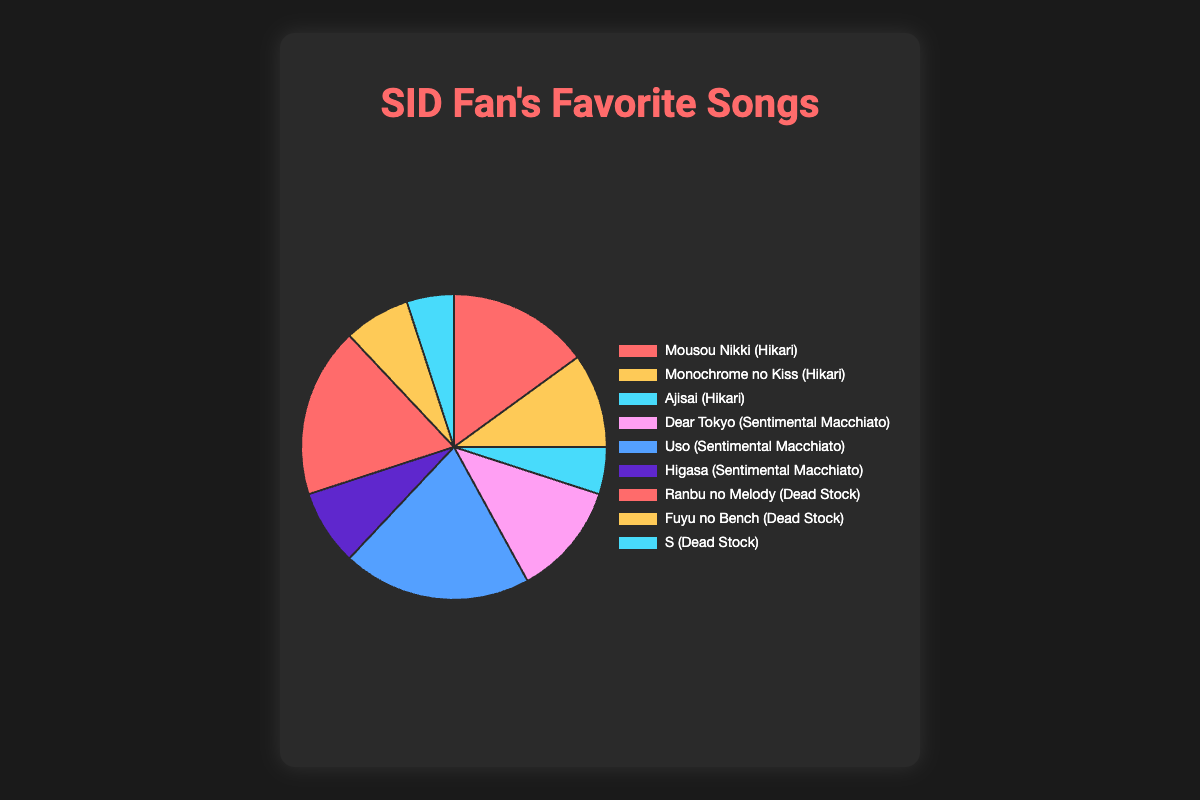Which song has the highest percentage of favorite votes among fans? The song "Uso" from "Sentimental Macchiato" has the highest percentage of favorite votes. From the pie chart, "Uso" is associated with the largest segment.
Answer: Uso Which album has the highest total percentage of favorite songs? Summing the percentages of the songs within each album: "Hikari" (15 + 10 + 5 = 30), "Sentimental Macchiato" (12 + 20 + 8 = 40), "Dead Stock" (18 + 7 + 5 = 30). "Sentimental Macchiato" has the highest total percentage.
Answer: Sentimental Macchiato What is the combined percentage of the least favorite songs from each album? The least favorite songs from each album are "Ajisai" (5) from "Hikari", "Higasa" (8) from "Sentimental Macchiato", and "S" (5) from "Dead Stock". Summing these gives (5 + 8 + 5 = 18).
Answer: 18 Which song from "Dead Stock" has the smallest percentage of favorite votes? From the "Dead Stock" album, the song with the smallest percentage is "S" with 5%.
Answer: S Is "Ranbu no Melody" more popular than "Dear Tokyo"? "Ranbu no Melody" has 18% while "Dear Tokyo" has 12%. Comparing these, "Ranbu no Melody" is more popular.
Answer: Yes What is the total percentage of favorite songs from the "Hikari" and "Dead Stock" albums combined? Combining the total percentages of "Hikari" (30) and "Dead Stock" (30) gives (30 + 30 = 60).
Answer: 60 Which song has the second lowest percentage of favorite votes from fans? The second lowest percentages are "Ajisai" and "S", both with 5%. However, since they have the same percentage, they share this position.
Answer: Ajisai and S What percentage of fans prefer "Monochrome no Kiss" over "Uso"? "Monochrome no Kiss" is preferred by 10% of fans whereas "Uso" is preferred by 20%. The percentage difference is (20 - 10 = 10).
Answer: 10 